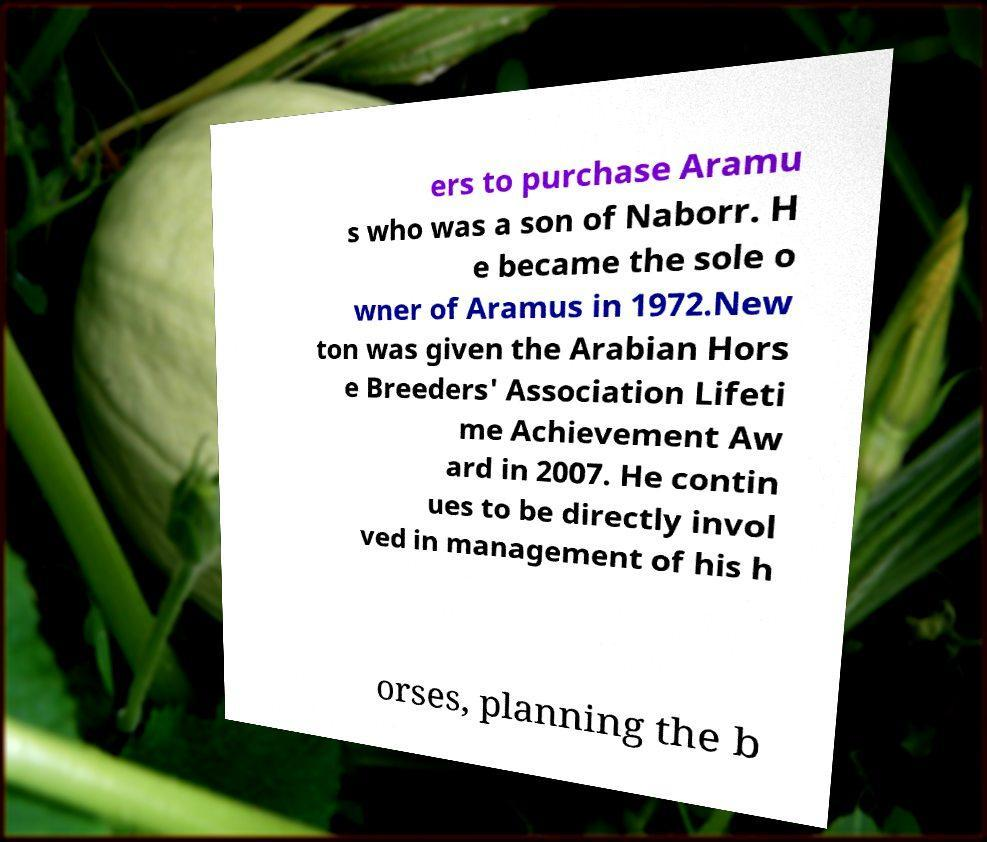Please identify and transcribe the text found in this image. ers to purchase Aramu s who was a son of Naborr. H e became the sole o wner of Aramus in 1972.New ton was given the Arabian Hors e Breeders' Association Lifeti me Achievement Aw ard in 2007. He contin ues to be directly invol ved in management of his h orses, planning the b 